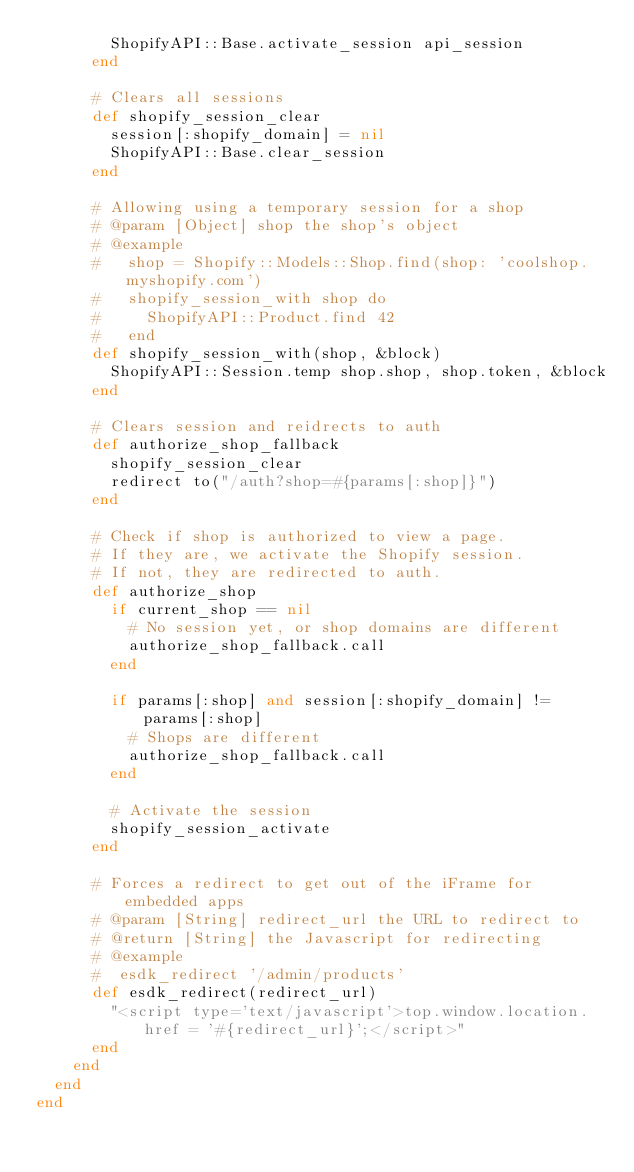Convert code to text. <code><loc_0><loc_0><loc_500><loc_500><_Ruby_>        ShopifyAPI::Base.activate_session api_session
      end

      # Clears all sessions
      def shopify_session_clear
        session[:shopify_domain] = nil
        ShopifyAPI::Base.clear_session
      end
      
      # Allowing using a temporary session for a shop
      # @param [Object] shop the shop's object
      # @example
      #   shop = Shopify::Models::Shop.find(shop: 'coolshop.myshopify.com')
      #   shopify_session_with shop do
      #     ShopifyAPI::Product.find 42
      #   end
      def shopify_session_with(shop, &block)
        ShopifyAPI::Session.temp shop.shop, shop.token, &block
      end
        
      # Clears session and reidrects to auth
      def authorize_shop_fallback
        shopify_session_clear
        redirect to("/auth?shop=#{params[:shop]}")
      end
      
      # Check if shop is authorized to view a page.
      # If they are, we activate the Shopify session.
      # If not, they are redirected to auth.
      def authorize_shop
        if current_shop == nil
          # No session yet, or shop domains are different
          authorize_shop_fallback.call
        end
        
        if params[:shop] and session[:shopify_domain] != params[:shop]
          # Shops are different
          authorize_shop_fallback.call
        end
        
        # Activate the session
        shopify_session_activate
      end
  
      # Forces a redirect to get out of the iFrame for embedded apps
      # @param [String] redirect_url the URL to redirect to
      # @return [String] the Javascript for redirecting
      # @example
      #  esdk_redirect '/admin/products'
      def esdk_redirect(redirect_url)
        "<script type='text/javascript'>top.window.location.href = '#{redirect_url}';</script>"
      end
    end
  end
end
</code> 